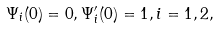<formula> <loc_0><loc_0><loc_500><loc_500>\Psi _ { i } ( 0 ) = 0 , \Psi _ { i } ^ { \prime } ( 0 ) = 1 , i = 1 , 2 ,</formula> 